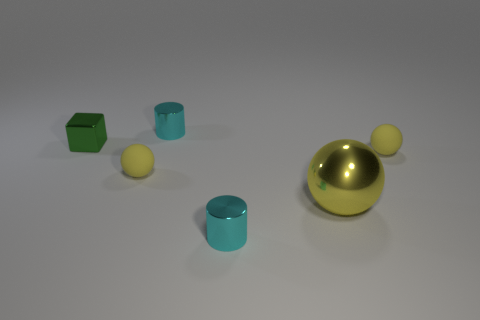There is a green shiny thing; are there any yellow balls in front of it?
Ensure brevity in your answer.  Yes. What number of cyan things are to the right of the metal thing that is behind the green object?
Make the answer very short. 1. Does the metal sphere have the same size as the matte ball that is on the left side of the big yellow metal sphere?
Your answer should be compact. No. Are there any tiny shiny blocks of the same color as the large ball?
Your answer should be very brief. No. What is the size of the yellow sphere that is made of the same material as the small green cube?
Your answer should be very brief. Large. Is the large sphere made of the same material as the green cube?
Make the answer very short. Yes. There is a rubber ball that is left of the small cyan metal object behind the cyan cylinder that is in front of the green thing; what color is it?
Ensure brevity in your answer.  Yellow. There is a big thing; what shape is it?
Make the answer very short. Sphere. There is a block; is its color the same as the cylinder that is in front of the small metal block?
Your answer should be compact. No. Are there the same number of small green objects that are left of the tiny green block and tiny red shiny cubes?
Make the answer very short. Yes. 